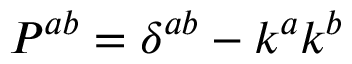<formula> <loc_0><loc_0><loc_500><loc_500>P ^ { a b } = \delta ^ { a b } - k ^ { a } k ^ { b }</formula> 